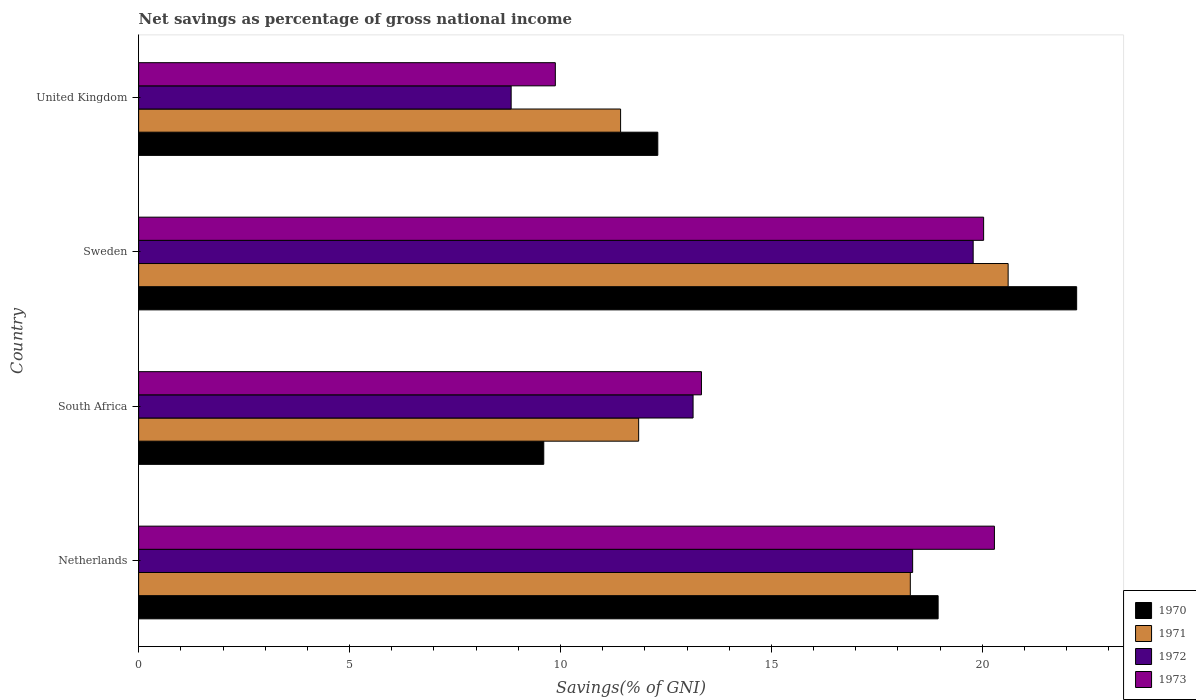How many different coloured bars are there?
Ensure brevity in your answer.  4. How many groups of bars are there?
Offer a terse response. 4. Are the number of bars per tick equal to the number of legend labels?
Your answer should be very brief. Yes. Are the number of bars on each tick of the Y-axis equal?
Keep it short and to the point. Yes. How many bars are there on the 1st tick from the top?
Ensure brevity in your answer.  4. What is the label of the 1st group of bars from the top?
Provide a succinct answer. United Kingdom. What is the total savings in 1971 in South Africa?
Your response must be concise. 11.85. Across all countries, what is the maximum total savings in 1970?
Offer a terse response. 22.24. Across all countries, what is the minimum total savings in 1972?
Give a very brief answer. 8.83. In which country was the total savings in 1972 minimum?
Your answer should be very brief. United Kingdom. What is the total total savings in 1973 in the graph?
Ensure brevity in your answer.  63.54. What is the difference between the total savings in 1973 in Netherlands and that in United Kingdom?
Offer a very short reply. 10.41. What is the difference between the total savings in 1973 in Sweden and the total savings in 1972 in South Africa?
Your response must be concise. 6.89. What is the average total savings in 1971 per country?
Your answer should be compact. 15.55. What is the difference between the total savings in 1972 and total savings in 1971 in South Africa?
Your answer should be compact. 1.29. In how many countries, is the total savings in 1971 greater than 6 %?
Offer a very short reply. 4. What is the ratio of the total savings in 1972 in Netherlands to that in United Kingdom?
Provide a short and direct response. 2.08. What is the difference between the highest and the second highest total savings in 1970?
Make the answer very short. 3.28. What is the difference between the highest and the lowest total savings in 1970?
Make the answer very short. 12.63. In how many countries, is the total savings in 1971 greater than the average total savings in 1971 taken over all countries?
Keep it short and to the point. 2. Is the sum of the total savings in 1973 in Netherlands and United Kingdom greater than the maximum total savings in 1971 across all countries?
Your answer should be compact. Yes. Is it the case that in every country, the sum of the total savings in 1971 and total savings in 1970 is greater than the sum of total savings in 1973 and total savings in 1972?
Make the answer very short. No. What is the difference between two consecutive major ticks on the X-axis?
Make the answer very short. 5. Are the values on the major ticks of X-axis written in scientific E-notation?
Make the answer very short. No. Does the graph contain any zero values?
Make the answer very short. No. Where does the legend appear in the graph?
Provide a succinct answer. Bottom right. What is the title of the graph?
Provide a short and direct response. Net savings as percentage of gross national income. Does "1969" appear as one of the legend labels in the graph?
Provide a short and direct response. No. What is the label or title of the X-axis?
Provide a succinct answer. Savings(% of GNI). What is the label or title of the Y-axis?
Your response must be concise. Country. What is the Savings(% of GNI) in 1970 in Netherlands?
Give a very brief answer. 18.95. What is the Savings(% of GNI) in 1971 in Netherlands?
Your response must be concise. 18.29. What is the Savings(% of GNI) of 1972 in Netherlands?
Your response must be concise. 18.35. What is the Savings(% of GNI) in 1973 in Netherlands?
Make the answer very short. 20.29. What is the Savings(% of GNI) in 1970 in South Africa?
Your answer should be compact. 9.6. What is the Savings(% of GNI) in 1971 in South Africa?
Offer a terse response. 11.85. What is the Savings(% of GNI) in 1972 in South Africa?
Your answer should be compact. 13.14. What is the Savings(% of GNI) of 1973 in South Africa?
Offer a very short reply. 13.34. What is the Savings(% of GNI) of 1970 in Sweden?
Offer a very short reply. 22.24. What is the Savings(% of GNI) in 1971 in Sweden?
Provide a short and direct response. 20.61. What is the Savings(% of GNI) of 1972 in Sweden?
Provide a succinct answer. 19.78. What is the Savings(% of GNI) of 1973 in Sweden?
Your answer should be very brief. 20.03. What is the Savings(% of GNI) of 1970 in United Kingdom?
Provide a short and direct response. 12.31. What is the Savings(% of GNI) of 1971 in United Kingdom?
Your response must be concise. 11.43. What is the Savings(% of GNI) of 1972 in United Kingdom?
Your answer should be very brief. 8.83. What is the Savings(% of GNI) in 1973 in United Kingdom?
Offer a very short reply. 9.88. Across all countries, what is the maximum Savings(% of GNI) of 1970?
Provide a succinct answer. 22.24. Across all countries, what is the maximum Savings(% of GNI) of 1971?
Provide a succinct answer. 20.61. Across all countries, what is the maximum Savings(% of GNI) in 1972?
Offer a very short reply. 19.78. Across all countries, what is the maximum Savings(% of GNI) in 1973?
Make the answer very short. 20.29. Across all countries, what is the minimum Savings(% of GNI) of 1970?
Your response must be concise. 9.6. Across all countries, what is the minimum Savings(% of GNI) of 1971?
Give a very brief answer. 11.43. Across all countries, what is the minimum Savings(% of GNI) in 1972?
Keep it short and to the point. 8.83. Across all countries, what is the minimum Savings(% of GNI) of 1973?
Keep it short and to the point. 9.88. What is the total Savings(% of GNI) of 1970 in the graph?
Your response must be concise. 63.1. What is the total Savings(% of GNI) in 1971 in the graph?
Make the answer very short. 62.19. What is the total Savings(% of GNI) in 1972 in the graph?
Your answer should be very brief. 60.11. What is the total Savings(% of GNI) of 1973 in the graph?
Your answer should be very brief. 63.54. What is the difference between the Savings(% of GNI) in 1970 in Netherlands and that in South Africa?
Your response must be concise. 9.35. What is the difference between the Savings(% of GNI) of 1971 in Netherlands and that in South Africa?
Give a very brief answer. 6.44. What is the difference between the Savings(% of GNI) in 1972 in Netherlands and that in South Africa?
Provide a succinct answer. 5.21. What is the difference between the Savings(% of GNI) of 1973 in Netherlands and that in South Africa?
Keep it short and to the point. 6.95. What is the difference between the Savings(% of GNI) of 1970 in Netherlands and that in Sweden?
Ensure brevity in your answer.  -3.28. What is the difference between the Savings(% of GNI) of 1971 in Netherlands and that in Sweden?
Your response must be concise. -2.32. What is the difference between the Savings(% of GNI) of 1972 in Netherlands and that in Sweden?
Your answer should be very brief. -1.43. What is the difference between the Savings(% of GNI) in 1973 in Netherlands and that in Sweden?
Give a very brief answer. 0.26. What is the difference between the Savings(% of GNI) of 1970 in Netherlands and that in United Kingdom?
Keep it short and to the point. 6.65. What is the difference between the Savings(% of GNI) of 1971 in Netherlands and that in United Kingdom?
Your answer should be very brief. 6.87. What is the difference between the Savings(% of GNI) in 1972 in Netherlands and that in United Kingdom?
Ensure brevity in your answer.  9.52. What is the difference between the Savings(% of GNI) of 1973 in Netherlands and that in United Kingdom?
Give a very brief answer. 10.41. What is the difference between the Savings(% of GNI) in 1970 in South Africa and that in Sweden?
Your answer should be compact. -12.63. What is the difference between the Savings(% of GNI) of 1971 in South Africa and that in Sweden?
Provide a short and direct response. -8.76. What is the difference between the Savings(% of GNI) in 1972 in South Africa and that in Sweden?
Offer a terse response. -6.64. What is the difference between the Savings(% of GNI) of 1973 in South Africa and that in Sweden?
Offer a very short reply. -6.69. What is the difference between the Savings(% of GNI) of 1970 in South Africa and that in United Kingdom?
Your response must be concise. -2.7. What is the difference between the Savings(% of GNI) of 1971 in South Africa and that in United Kingdom?
Your response must be concise. 0.43. What is the difference between the Savings(% of GNI) of 1972 in South Africa and that in United Kingdom?
Your answer should be compact. 4.31. What is the difference between the Savings(% of GNI) of 1973 in South Africa and that in United Kingdom?
Offer a terse response. 3.46. What is the difference between the Savings(% of GNI) of 1970 in Sweden and that in United Kingdom?
Your response must be concise. 9.93. What is the difference between the Savings(% of GNI) of 1971 in Sweden and that in United Kingdom?
Provide a succinct answer. 9.19. What is the difference between the Savings(% of GNI) in 1972 in Sweden and that in United Kingdom?
Your response must be concise. 10.95. What is the difference between the Savings(% of GNI) of 1973 in Sweden and that in United Kingdom?
Give a very brief answer. 10.15. What is the difference between the Savings(% of GNI) in 1970 in Netherlands and the Savings(% of GNI) in 1971 in South Africa?
Make the answer very short. 7.1. What is the difference between the Savings(% of GNI) in 1970 in Netherlands and the Savings(% of GNI) in 1972 in South Africa?
Offer a very short reply. 5.81. What is the difference between the Savings(% of GNI) in 1970 in Netherlands and the Savings(% of GNI) in 1973 in South Africa?
Give a very brief answer. 5.61. What is the difference between the Savings(% of GNI) of 1971 in Netherlands and the Savings(% of GNI) of 1972 in South Africa?
Provide a short and direct response. 5.15. What is the difference between the Savings(% of GNI) in 1971 in Netherlands and the Savings(% of GNI) in 1973 in South Africa?
Your response must be concise. 4.95. What is the difference between the Savings(% of GNI) of 1972 in Netherlands and the Savings(% of GNI) of 1973 in South Africa?
Your answer should be compact. 5.01. What is the difference between the Savings(% of GNI) of 1970 in Netherlands and the Savings(% of GNI) of 1971 in Sweden?
Offer a very short reply. -1.66. What is the difference between the Savings(% of GNI) in 1970 in Netherlands and the Savings(% of GNI) in 1972 in Sweden?
Your answer should be very brief. -0.83. What is the difference between the Savings(% of GNI) of 1970 in Netherlands and the Savings(% of GNI) of 1973 in Sweden?
Your response must be concise. -1.08. What is the difference between the Savings(% of GNI) of 1971 in Netherlands and the Savings(% of GNI) of 1972 in Sweden?
Your answer should be very brief. -1.49. What is the difference between the Savings(% of GNI) of 1971 in Netherlands and the Savings(% of GNI) of 1973 in Sweden?
Make the answer very short. -1.74. What is the difference between the Savings(% of GNI) in 1972 in Netherlands and the Savings(% of GNI) in 1973 in Sweden?
Provide a short and direct response. -1.68. What is the difference between the Savings(% of GNI) in 1970 in Netherlands and the Savings(% of GNI) in 1971 in United Kingdom?
Offer a terse response. 7.53. What is the difference between the Savings(% of GNI) of 1970 in Netherlands and the Savings(% of GNI) of 1972 in United Kingdom?
Offer a terse response. 10.12. What is the difference between the Savings(% of GNI) of 1970 in Netherlands and the Savings(% of GNI) of 1973 in United Kingdom?
Provide a short and direct response. 9.07. What is the difference between the Savings(% of GNI) of 1971 in Netherlands and the Savings(% of GNI) of 1972 in United Kingdom?
Provide a short and direct response. 9.46. What is the difference between the Savings(% of GNI) in 1971 in Netherlands and the Savings(% of GNI) in 1973 in United Kingdom?
Ensure brevity in your answer.  8.42. What is the difference between the Savings(% of GNI) of 1972 in Netherlands and the Savings(% of GNI) of 1973 in United Kingdom?
Give a very brief answer. 8.47. What is the difference between the Savings(% of GNI) in 1970 in South Africa and the Savings(% of GNI) in 1971 in Sweden?
Give a very brief answer. -11.01. What is the difference between the Savings(% of GNI) of 1970 in South Africa and the Savings(% of GNI) of 1972 in Sweden?
Keep it short and to the point. -10.18. What is the difference between the Savings(% of GNI) of 1970 in South Africa and the Savings(% of GNI) of 1973 in Sweden?
Offer a very short reply. -10.43. What is the difference between the Savings(% of GNI) in 1971 in South Africa and the Savings(% of GNI) in 1972 in Sweden?
Ensure brevity in your answer.  -7.93. What is the difference between the Savings(% of GNI) of 1971 in South Africa and the Savings(% of GNI) of 1973 in Sweden?
Provide a short and direct response. -8.18. What is the difference between the Savings(% of GNI) of 1972 in South Africa and the Savings(% of GNI) of 1973 in Sweden?
Your response must be concise. -6.89. What is the difference between the Savings(% of GNI) in 1970 in South Africa and the Savings(% of GNI) in 1971 in United Kingdom?
Make the answer very short. -1.82. What is the difference between the Savings(% of GNI) of 1970 in South Africa and the Savings(% of GNI) of 1972 in United Kingdom?
Your answer should be very brief. 0.77. What is the difference between the Savings(% of GNI) of 1970 in South Africa and the Savings(% of GNI) of 1973 in United Kingdom?
Keep it short and to the point. -0.27. What is the difference between the Savings(% of GNI) of 1971 in South Africa and the Savings(% of GNI) of 1972 in United Kingdom?
Keep it short and to the point. 3.02. What is the difference between the Savings(% of GNI) of 1971 in South Africa and the Savings(% of GNI) of 1973 in United Kingdom?
Provide a succinct answer. 1.98. What is the difference between the Savings(% of GNI) of 1972 in South Africa and the Savings(% of GNI) of 1973 in United Kingdom?
Provide a succinct answer. 3.27. What is the difference between the Savings(% of GNI) in 1970 in Sweden and the Savings(% of GNI) in 1971 in United Kingdom?
Offer a terse response. 10.81. What is the difference between the Savings(% of GNI) of 1970 in Sweden and the Savings(% of GNI) of 1972 in United Kingdom?
Ensure brevity in your answer.  13.41. What is the difference between the Savings(% of GNI) of 1970 in Sweden and the Savings(% of GNI) of 1973 in United Kingdom?
Offer a very short reply. 12.36. What is the difference between the Savings(% of GNI) of 1971 in Sweden and the Savings(% of GNI) of 1972 in United Kingdom?
Offer a terse response. 11.78. What is the difference between the Savings(% of GNI) of 1971 in Sweden and the Savings(% of GNI) of 1973 in United Kingdom?
Provide a succinct answer. 10.73. What is the difference between the Savings(% of GNI) in 1972 in Sweden and the Savings(% of GNI) in 1973 in United Kingdom?
Your answer should be compact. 9.91. What is the average Savings(% of GNI) in 1970 per country?
Provide a short and direct response. 15.78. What is the average Savings(% of GNI) in 1971 per country?
Make the answer very short. 15.55. What is the average Savings(% of GNI) of 1972 per country?
Keep it short and to the point. 15.03. What is the average Savings(% of GNI) in 1973 per country?
Give a very brief answer. 15.88. What is the difference between the Savings(% of GNI) in 1970 and Savings(% of GNI) in 1971 in Netherlands?
Provide a succinct answer. 0.66. What is the difference between the Savings(% of GNI) in 1970 and Savings(% of GNI) in 1972 in Netherlands?
Your response must be concise. 0.6. What is the difference between the Savings(% of GNI) of 1970 and Savings(% of GNI) of 1973 in Netherlands?
Ensure brevity in your answer.  -1.33. What is the difference between the Savings(% of GNI) in 1971 and Savings(% of GNI) in 1972 in Netherlands?
Your answer should be compact. -0.06. What is the difference between the Savings(% of GNI) in 1971 and Savings(% of GNI) in 1973 in Netherlands?
Your answer should be very brief. -1.99. What is the difference between the Savings(% of GNI) of 1972 and Savings(% of GNI) of 1973 in Netherlands?
Your response must be concise. -1.94. What is the difference between the Savings(% of GNI) of 1970 and Savings(% of GNI) of 1971 in South Africa?
Provide a succinct answer. -2.25. What is the difference between the Savings(% of GNI) of 1970 and Savings(% of GNI) of 1972 in South Africa?
Give a very brief answer. -3.54. What is the difference between the Savings(% of GNI) of 1970 and Savings(% of GNI) of 1973 in South Africa?
Provide a succinct answer. -3.74. What is the difference between the Savings(% of GNI) of 1971 and Savings(% of GNI) of 1972 in South Africa?
Ensure brevity in your answer.  -1.29. What is the difference between the Savings(% of GNI) of 1971 and Savings(% of GNI) of 1973 in South Africa?
Your answer should be very brief. -1.49. What is the difference between the Savings(% of GNI) in 1972 and Savings(% of GNI) in 1973 in South Africa?
Provide a succinct answer. -0.2. What is the difference between the Savings(% of GNI) in 1970 and Savings(% of GNI) in 1971 in Sweden?
Ensure brevity in your answer.  1.62. What is the difference between the Savings(% of GNI) in 1970 and Savings(% of GNI) in 1972 in Sweden?
Give a very brief answer. 2.45. What is the difference between the Savings(% of GNI) of 1970 and Savings(% of GNI) of 1973 in Sweden?
Give a very brief answer. 2.21. What is the difference between the Savings(% of GNI) in 1971 and Savings(% of GNI) in 1972 in Sweden?
Make the answer very short. 0.83. What is the difference between the Savings(% of GNI) of 1971 and Savings(% of GNI) of 1973 in Sweden?
Ensure brevity in your answer.  0.58. What is the difference between the Savings(% of GNI) of 1972 and Savings(% of GNI) of 1973 in Sweden?
Make the answer very short. -0.25. What is the difference between the Savings(% of GNI) of 1970 and Savings(% of GNI) of 1971 in United Kingdom?
Offer a very short reply. 0.88. What is the difference between the Savings(% of GNI) of 1970 and Savings(% of GNI) of 1972 in United Kingdom?
Your answer should be compact. 3.48. What is the difference between the Savings(% of GNI) of 1970 and Savings(% of GNI) of 1973 in United Kingdom?
Provide a short and direct response. 2.43. What is the difference between the Savings(% of GNI) in 1971 and Savings(% of GNI) in 1972 in United Kingdom?
Offer a very short reply. 2.59. What is the difference between the Savings(% of GNI) in 1971 and Savings(% of GNI) in 1973 in United Kingdom?
Your answer should be very brief. 1.55. What is the difference between the Savings(% of GNI) of 1972 and Savings(% of GNI) of 1973 in United Kingdom?
Make the answer very short. -1.05. What is the ratio of the Savings(% of GNI) in 1970 in Netherlands to that in South Africa?
Make the answer very short. 1.97. What is the ratio of the Savings(% of GNI) of 1971 in Netherlands to that in South Africa?
Give a very brief answer. 1.54. What is the ratio of the Savings(% of GNI) in 1972 in Netherlands to that in South Africa?
Offer a very short reply. 1.4. What is the ratio of the Savings(% of GNI) in 1973 in Netherlands to that in South Africa?
Give a very brief answer. 1.52. What is the ratio of the Savings(% of GNI) of 1970 in Netherlands to that in Sweden?
Ensure brevity in your answer.  0.85. What is the ratio of the Savings(% of GNI) in 1971 in Netherlands to that in Sweden?
Your answer should be very brief. 0.89. What is the ratio of the Savings(% of GNI) in 1972 in Netherlands to that in Sweden?
Keep it short and to the point. 0.93. What is the ratio of the Savings(% of GNI) of 1973 in Netherlands to that in Sweden?
Make the answer very short. 1.01. What is the ratio of the Savings(% of GNI) in 1970 in Netherlands to that in United Kingdom?
Your response must be concise. 1.54. What is the ratio of the Savings(% of GNI) of 1971 in Netherlands to that in United Kingdom?
Your answer should be compact. 1.6. What is the ratio of the Savings(% of GNI) in 1972 in Netherlands to that in United Kingdom?
Your answer should be compact. 2.08. What is the ratio of the Savings(% of GNI) of 1973 in Netherlands to that in United Kingdom?
Offer a terse response. 2.05. What is the ratio of the Savings(% of GNI) of 1970 in South Africa to that in Sweden?
Your answer should be very brief. 0.43. What is the ratio of the Savings(% of GNI) in 1971 in South Africa to that in Sweden?
Provide a short and direct response. 0.58. What is the ratio of the Savings(% of GNI) of 1972 in South Africa to that in Sweden?
Provide a short and direct response. 0.66. What is the ratio of the Savings(% of GNI) in 1973 in South Africa to that in Sweden?
Your answer should be very brief. 0.67. What is the ratio of the Savings(% of GNI) in 1970 in South Africa to that in United Kingdom?
Make the answer very short. 0.78. What is the ratio of the Savings(% of GNI) in 1971 in South Africa to that in United Kingdom?
Your answer should be compact. 1.04. What is the ratio of the Savings(% of GNI) of 1972 in South Africa to that in United Kingdom?
Offer a very short reply. 1.49. What is the ratio of the Savings(% of GNI) in 1973 in South Africa to that in United Kingdom?
Offer a terse response. 1.35. What is the ratio of the Savings(% of GNI) of 1970 in Sweden to that in United Kingdom?
Keep it short and to the point. 1.81. What is the ratio of the Savings(% of GNI) in 1971 in Sweden to that in United Kingdom?
Offer a terse response. 1.8. What is the ratio of the Savings(% of GNI) of 1972 in Sweden to that in United Kingdom?
Provide a succinct answer. 2.24. What is the ratio of the Savings(% of GNI) of 1973 in Sweden to that in United Kingdom?
Offer a terse response. 2.03. What is the difference between the highest and the second highest Savings(% of GNI) of 1970?
Offer a terse response. 3.28. What is the difference between the highest and the second highest Savings(% of GNI) in 1971?
Make the answer very short. 2.32. What is the difference between the highest and the second highest Savings(% of GNI) of 1972?
Make the answer very short. 1.43. What is the difference between the highest and the second highest Savings(% of GNI) in 1973?
Your answer should be compact. 0.26. What is the difference between the highest and the lowest Savings(% of GNI) in 1970?
Provide a succinct answer. 12.63. What is the difference between the highest and the lowest Savings(% of GNI) in 1971?
Offer a very short reply. 9.19. What is the difference between the highest and the lowest Savings(% of GNI) of 1972?
Your answer should be very brief. 10.95. What is the difference between the highest and the lowest Savings(% of GNI) of 1973?
Offer a terse response. 10.41. 